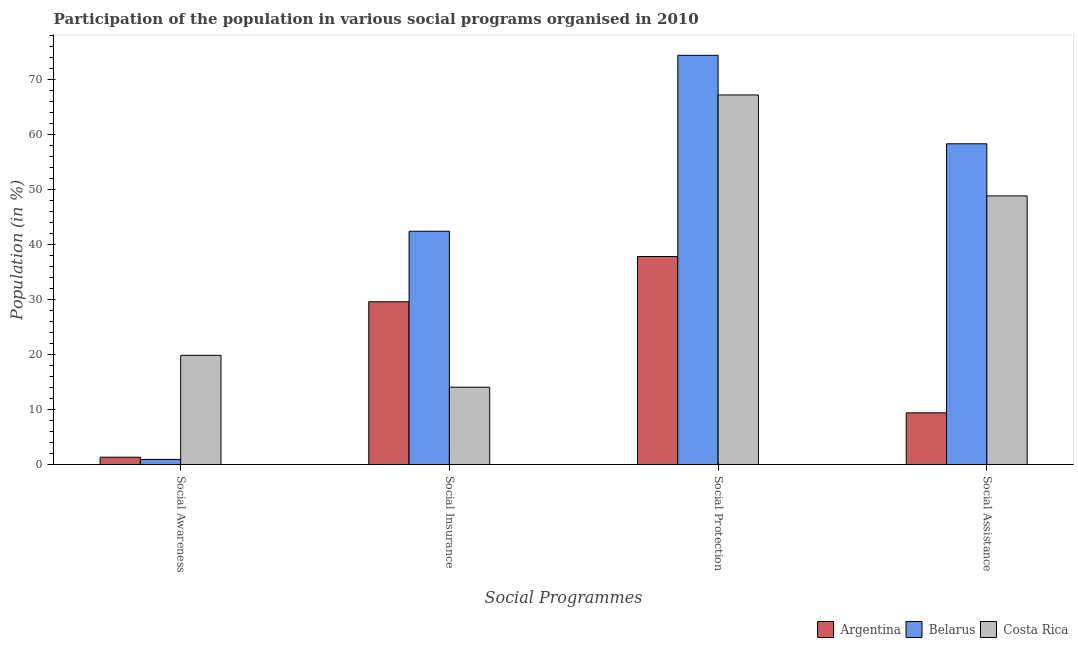How many groups of bars are there?
Provide a short and direct response. 4. Are the number of bars on each tick of the X-axis equal?
Your response must be concise. Yes. What is the label of the 2nd group of bars from the left?
Give a very brief answer. Social Insurance. What is the participation of population in social insurance programs in Costa Rica?
Make the answer very short. 14.05. Across all countries, what is the maximum participation of population in social protection programs?
Provide a short and direct response. 74.35. Across all countries, what is the minimum participation of population in social insurance programs?
Provide a short and direct response. 14.05. In which country was the participation of population in social assistance programs maximum?
Provide a succinct answer. Belarus. In which country was the participation of population in social insurance programs minimum?
Ensure brevity in your answer.  Costa Rica. What is the total participation of population in social assistance programs in the graph?
Provide a succinct answer. 116.48. What is the difference between the participation of population in social protection programs in Belarus and that in Costa Rica?
Offer a very short reply. 7.2. What is the difference between the participation of population in social assistance programs in Costa Rica and the participation of population in social insurance programs in Argentina?
Offer a very short reply. 19.23. What is the average participation of population in social protection programs per country?
Your answer should be very brief. 59.77. What is the difference between the participation of population in social assistance programs and participation of population in social insurance programs in Costa Rica?
Your answer should be compact. 34.76. In how many countries, is the participation of population in social assistance programs greater than 62 %?
Keep it short and to the point. 0. What is the ratio of the participation of population in social awareness programs in Belarus to that in Argentina?
Make the answer very short. 0.7. Is the participation of population in social protection programs in Costa Rica less than that in Argentina?
Your answer should be very brief. No. What is the difference between the highest and the second highest participation of population in social insurance programs?
Offer a terse response. 12.81. What is the difference between the highest and the lowest participation of population in social insurance programs?
Ensure brevity in your answer.  28.34. Is the sum of the participation of population in social awareness programs in Costa Rica and Belarus greater than the maximum participation of population in social protection programs across all countries?
Your answer should be very brief. No. Is it the case that in every country, the sum of the participation of population in social awareness programs and participation of population in social insurance programs is greater than the participation of population in social protection programs?
Your answer should be compact. No. How many bars are there?
Your answer should be compact. 12. Are all the bars in the graph horizontal?
Give a very brief answer. No. Does the graph contain any zero values?
Offer a very short reply. No. How many legend labels are there?
Offer a very short reply. 3. How are the legend labels stacked?
Your answer should be very brief. Horizontal. What is the title of the graph?
Provide a short and direct response. Participation of the population in various social programs organised in 2010. What is the label or title of the X-axis?
Your response must be concise. Social Programmes. What is the Population (in %) in Argentina in Social Awareness?
Offer a very short reply. 1.33. What is the Population (in %) in Belarus in Social Awareness?
Your answer should be very brief. 0.93. What is the Population (in %) in Costa Rica in Social Awareness?
Make the answer very short. 19.84. What is the Population (in %) of Argentina in Social Insurance?
Provide a succinct answer. 29.58. What is the Population (in %) of Belarus in Social Insurance?
Offer a very short reply. 42.39. What is the Population (in %) in Costa Rica in Social Insurance?
Your answer should be very brief. 14.05. What is the Population (in %) of Argentina in Social Protection?
Offer a very short reply. 37.8. What is the Population (in %) in Belarus in Social Protection?
Keep it short and to the point. 74.35. What is the Population (in %) in Costa Rica in Social Protection?
Provide a succinct answer. 67.15. What is the Population (in %) of Argentina in Social Assistance?
Your response must be concise. 9.39. What is the Population (in %) of Belarus in Social Assistance?
Offer a very short reply. 58.28. What is the Population (in %) in Costa Rica in Social Assistance?
Offer a terse response. 48.81. Across all Social Programmes, what is the maximum Population (in %) of Argentina?
Provide a succinct answer. 37.8. Across all Social Programmes, what is the maximum Population (in %) of Belarus?
Make the answer very short. 74.35. Across all Social Programmes, what is the maximum Population (in %) in Costa Rica?
Your answer should be very brief. 67.15. Across all Social Programmes, what is the minimum Population (in %) in Argentina?
Your response must be concise. 1.33. Across all Social Programmes, what is the minimum Population (in %) of Belarus?
Offer a very short reply. 0.93. Across all Social Programmes, what is the minimum Population (in %) in Costa Rica?
Make the answer very short. 14.05. What is the total Population (in %) in Argentina in the graph?
Your answer should be compact. 78.1. What is the total Population (in %) in Belarus in the graph?
Provide a short and direct response. 175.95. What is the total Population (in %) in Costa Rica in the graph?
Provide a succinct answer. 149.85. What is the difference between the Population (in %) in Argentina in Social Awareness and that in Social Insurance?
Offer a very short reply. -28.24. What is the difference between the Population (in %) in Belarus in Social Awareness and that in Social Insurance?
Your response must be concise. -41.46. What is the difference between the Population (in %) in Costa Rica in Social Awareness and that in Social Insurance?
Provide a succinct answer. 5.79. What is the difference between the Population (in %) of Argentina in Social Awareness and that in Social Protection?
Make the answer very short. -36.47. What is the difference between the Population (in %) in Belarus in Social Awareness and that in Social Protection?
Your response must be concise. -73.42. What is the difference between the Population (in %) in Costa Rica in Social Awareness and that in Social Protection?
Give a very brief answer. -47.31. What is the difference between the Population (in %) of Argentina in Social Awareness and that in Social Assistance?
Make the answer very short. -8.06. What is the difference between the Population (in %) in Belarus in Social Awareness and that in Social Assistance?
Make the answer very short. -57.34. What is the difference between the Population (in %) in Costa Rica in Social Awareness and that in Social Assistance?
Ensure brevity in your answer.  -28.97. What is the difference between the Population (in %) of Argentina in Social Insurance and that in Social Protection?
Provide a short and direct response. -8.23. What is the difference between the Population (in %) of Belarus in Social Insurance and that in Social Protection?
Keep it short and to the point. -31.96. What is the difference between the Population (in %) of Costa Rica in Social Insurance and that in Social Protection?
Ensure brevity in your answer.  -53.1. What is the difference between the Population (in %) in Argentina in Social Insurance and that in Social Assistance?
Provide a short and direct response. 20.18. What is the difference between the Population (in %) in Belarus in Social Insurance and that in Social Assistance?
Provide a succinct answer. -15.89. What is the difference between the Population (in %) of Costa Rica in Social Insurance and that in Social Assistance?
Keep it short and to the point. -34.76. What is the difference between the Population (in %) in Argentina in Social Protection and that in Social Assistance?
Offer a very short reply. 28.41. What is the difference between the Population (in %) in Belarus in Social Protection and that in Social Assistance?
Give a very brief answer. 16.07. What is the difference between the Population (in %) of Costa Rica in Social Protection and that in Social Assistance?
Offer a terse response. 18.34. What is the difference between the Population (in %) in Argentina in Social Awareness and the Population (in %) in Belarus in Social Insurance?
Your answer should be very brief. -41.06. What is the difference between the Population (in %) of Argentina in Social Awareness and the Population (in %) of Costa Rica in Social Insurance?
Provide a succinct answer. -12.72. What is the difference between the Population (in %) of Belarus in Social Awareness and the Population (in %) of Costa Rica in Social Insurance?
Offer a terse response. -13.12. What is the difference between the Population (in %) in Argentina in Social Awareness and the Population (in %) in Belarus in Social Protection?
Your answer should be very brief. -73.02. What is the difference between the Population (in %) in Argentina in Social Awareness and the Population (in %) in Costa Rica in Social Protection?
Provide a succinct answer. -65.82. What is the difference between the Population (in %) of Belarus in Social Awareness and the Population (in %) of Costa Rica in Social Protection?
Your answer should be compact. -66.22. What is the difference between the Population (in %) of Argentina in Social Awareness and the Population (in %) of Belarus in Social Assistance?
Make the answer very short. -56.95. What is the difference between the Population (in %) of Argentina in Social Awareness and the Population (in %) of Costa Rica in Social Assistance?
Your answer should be very brief. -47.48. What is the difference between the Population (in %) in Belarus in Social Awareness and the Population (in %) in Costa Rica in Social Assistance?
Your answer should be very brief. -47.88. What is the difference between the Population (in %) in Argentina in Social Insurance and the Population (in %) in Belarus in Social Protection?
Provide a succinct answer. -44.77. What is the difference between the Population (in %) of Argentina in Social Insurance and the Population (in %) of Costa Rica in Social Protection?
Ensure brevity in your answer.  -37.58. What is the difference between the Population (in %) of Belarus in Social Insurance and the Population (in %) of Costa Rica in Social Protection?
Give a very brief answer. -24.76. What is the difference between the Population (in %) in Argentina in Social Insurance and the Population (in %) in Belarus in Social Assistance?
Provide a succinct answer. -28.7. What is the difference between the Population (in %) of Argentina in Social Insurance and the Population (in %) of Costa Rica in Social Assistance?
Provide a short and direct response. -19.23. What is the difference between the Population (in %) in Belarus in Social Insurance and the Population (in %) in Costa Rica in Social Assistance?
Ensure brevity in your answer.  -6.42. What is the difference between the Population (in %) in Argentina in Social Protection and the Population (in %) in Belarus in Social Assistance?
Keep it short and to the point. -20.48. What is the difference between the Population (in %) of Argentina in Social Protection and the Population (in %) of Costa Rica in Social Assistance?
Make the answer very short. -11.01. What is the difference between the Population (in %) in Belarus in Social Protection and the Population (in %) in Costa Rica in Social Assistance?
Your response must be concise. 25.54. What is the average Population (in %) of Argentina per Social Programmes?
Your answer should be compact. 19.53. What is the average Population (in %) of Belarus per Social Programmes?
Your answer should be very brief. 43.99. What is the average Population (in %) of Costa Rica per Social Programmes?
Your response must be concise. 37.46. What is the difference between the Population (in %) in Argentina and Population (in %) in Belarus in Social Awareness?
Provide a succinct answer. 0.4. What is the difference between the Population (in %) in Argentina and Population (in %) in Costa Rica in Social Awareness?
Keep it short and to the point. -18.51. What is the difference between the Population (in %) in Belarus and Population (in %) in Costa Rica in Social Awareness?
Give a very brief answer. -18.91. What is the difference between the Population (in %) of Argentina and Population (in %) of Belarus in Social Insurance?
Provide a succinct answer. -12.81. What is the difference between the Population (in %) in Argentina and Population (in %) in Costa Rica in Social Insurance?
Provide a succinct answer. 15.52. What is the difference between the Population (in %) in Belarus and Population (in %) in Costa Rica in Social Insurance?
Give a very brief answer. 28.34. What is the difference between the Population (in %) of Argentina and Population (in %) of Belarus in Social Protection?
Keep it short and to the point. -36.55. What is the difference between the Population (in %) in Argentina and Population (in %) in Costa Rica in Social Protection?
Make the answer very short. -29.35. What is the difference between the Population (in %) of Belarus and Population (in %) of Costa Rica in Social Protection?
Your answer should be very brief. 7.2. What is the difference between the Population (in %) of Argentina and Population (in %) of Belarus in Social Assistance?
Provide a short and direct response. -48.88. What is the difference between the Population (in %) of Argentina and Population (in %) of Costa Rica in Social Assistance?
Your answer should be very brief. -39.41. What is the difference between the Population (in %) of Belarus and Population (in %) of Costa Rica in Social Assistance?
Your response must be concise. 9.47. What is the ratio of the Population (in %) of Argentina in Social Awareness to that in Social Insurance?
Keep it short and to the point. 0.04. What is the ratio of the Population (in %) of Belarus in Social Awareness to that in Social Insurance?
Ensure brevity in your answer.  0.02. What is the ratio of the Population (in %) in Costa Rica in Social Awareness to that in Social Insurance?
Provide a short and direct response. 1.41. What is the ratio of the Population (in %) of Argentina in Social Awareness to that in Social Protection?
Offer a terse response. 0.04. What is the ratio of the Population (in %) of Belarus in Social Awareness to that in Social Protection?
Make the answer very short. 0.01. What is the ratio of the Population (in %) in Costa Rica in Social Awareness to that in Social Protection?
Give a very brief answer. 0.3. What is the ratio of the Population (in %) of Argentina in Social Awareness to that in Social Assistance?
Provide a short and direct response. 0.14. What is the ratio of the Population (in %) in Belarus in Social Awareness to that in Social Assistance?
Give a very brief answer. 0.02. What is the ratio of the Population (in %) of Costa Rica in Social Awareness to that in Social Assistance?
Give a very brief answer. 0.41. What is the ratio of the Population (in %) in Argentina in Social Insurance to that in Social Protection?
Your response must be concise. 0.78. What is the ratio of the Population (in %) in Belarus in Social Insurance to that in Social Protection?
Offer a terse response. 0.57. What is the ratio of the Population (in %) in Costa Rica in Social Insurance to that in Social Protection?
Your answer should be very brief. 0.21. What is the ratio of the Population (in %) in Argentina in Social Insurance to that in Social Assistance?
Your answer should be compact. 3.15. What is the ratio of the Population (in %) in Belarus in Social Insurance to that in Social Assistance?
Give a very brief answer. 0.73. What is the ratio of the Population (in %) in Costa Rica in Social Insurance to that in Social Assistance?
Offer a terse response. 0.29. What is the ratio of the Population (in %) in Argentina in Social Protection to that in Social Assistance?
Your answer should be very brief. 4.02. What is the ratio of the Population (in %) of Belarus in Social Protection to that in Social Assistance?
Your answer should be compact. 1.28. What is the ratio of the Population (in %) in Costa Rica in Social Protection to that in Social Assistance?
Your response must be concise. 1.38. What is the difference between the highest and the second highest Population (in %) of Argentina?
Provide a short and direct response. 8.23. What is the difference between the highest and the second highest Population (in %) in Belarus?
Offer a terse response. 16.07. What is the difference between the highest and the second highest Population (in %) of Costa Rica?
Give a very brief answer. 18.34. What is the difference between the highest and the lowest Population (in %) in Argentina?
Ensure brevity in your answer.  36.47. What is the difference between the highest and the lowest Population (in %) in Belarus?
Your answer should be very brief. 73.42. What is the difference between the highest and the lowest Population (in %) of Costa Rica?
Keep it short and to the point. 53.1. 